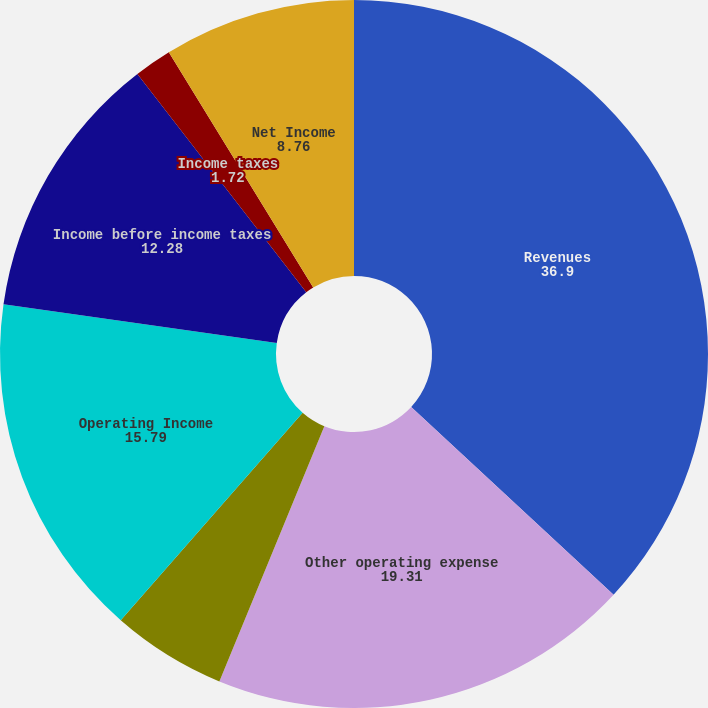Convert chart. <chart><loc_0><loc_0><loc_500><loc_500><pie_chart><fcel>Revenues<fcel>Other operating expense<fcel>Provision for depreciation<fcel>Operating Income<fcel>Income before income taxes<fcel>Income taxes<fcel>Net Income<nl><fcel>36.9%<fcel>19.31%<fcel>5.24%<fcel>15.79%<fcel>12.28%<fcel>1.72%<fcel>8.76%<nl></chart> 